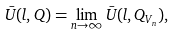<formula> <loc_0><loc_0><loc_500><loc_500>\bar { U } ( l , Q ) = \lim _ { n \rightarrow \infty } \bar { U } ( l , Q _ { V _ { n } } ) ,</formula> 